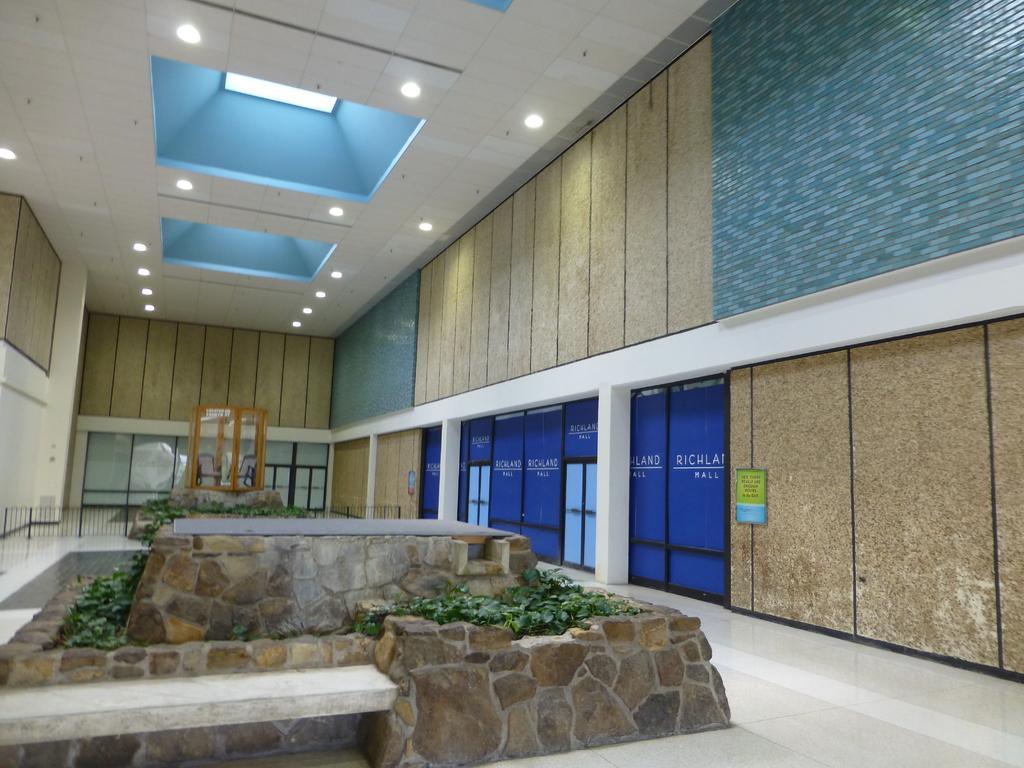Can you describe this image briefly? This picture is taken inside the room. In this image, on the right side, we can see a wall, glass door and a frame is attached to a wall. On the left side, we can also see a wall. In the middle of the image, we can see a wall which is made of stones, plants. In the background, we can see a glass door. At the top, we can see a roof with few light, at the bottom, we can see a floor. 